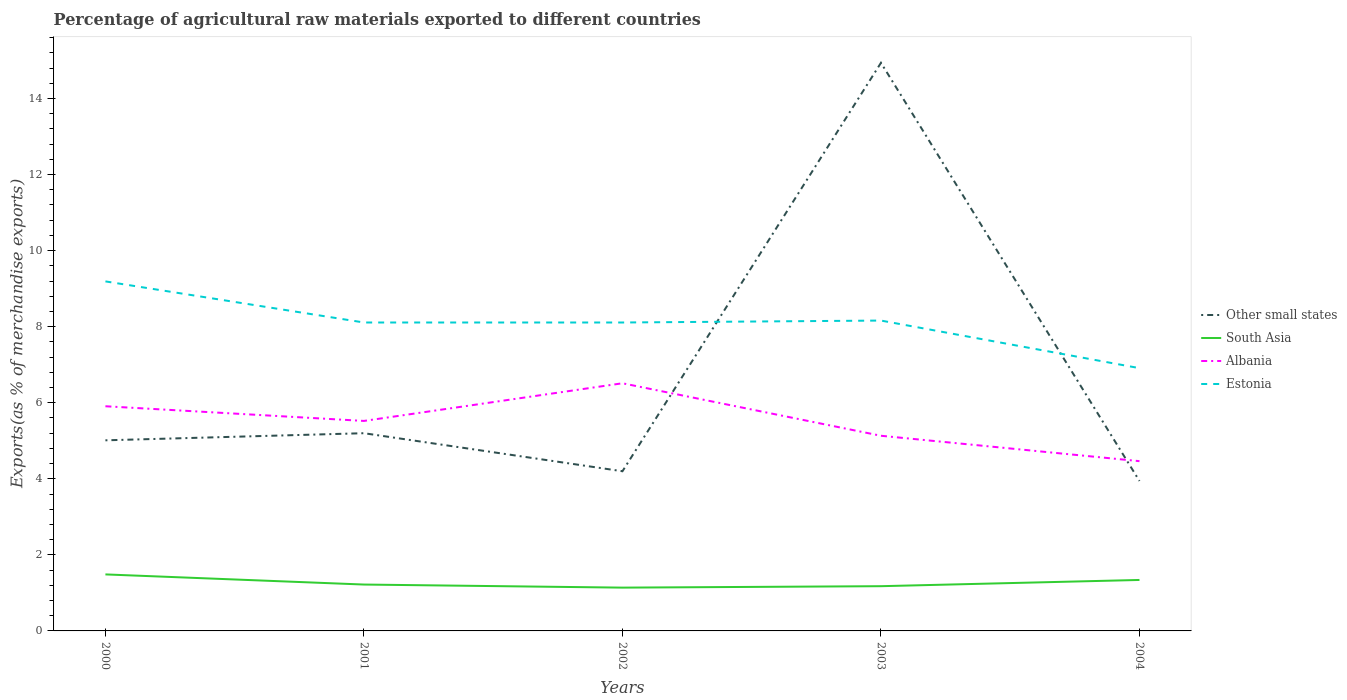Is the number of lines equal to the number of legend labels?
Make the answer very short. Yes. Across all years, what is the maximum percentage of exports to different countries in South Asia?
Provide a succinct answer. 1.14. In which year was the percentage of exports to different countries in Estonia maximum?
Offer a very short reply. 2004. What is the total percentage of exports to different countries in Albania in the graph?
Provide a succinct answer. -0.99. What is the difference between the highest and the second highest percentage of exports to different countries in Estonia?
Provide a short and direct response. 2.28. What is the difference between the highest and the lowest percentage of exports to different countries in Estonia?
Make the answer very short. 4. What is the difference between two consecutive major ticks on the Y-axis?
Your response must be concise. 2. Are the values on the major ticks of Y-axis written in scientific E-notation?
Provide a succinct answer. No. Does the graph contain any zero values?
Your response must be concise. No. Does the graph contain grids?
Keep it short and to the point. No. Where does the legend appear in the graph?
Give a very brief answer. Center right. How are the legend labels stacked?
Keep it short and to the point. Vertical. What is the title of the graph?
Give a very brief answer. Percentage of agricultural raw materials exported to different countries. What is the label or title of the Y-axis?
Your answer should be compact. Exports(as % of merchandise exports). What is the Exports(as % of merchandise exports) of Other small states in 2000?
Offer a very short reply. 5.01. What is the Exports(as % of merchandise exports) in South Asia in 2000?
Make the answer very short. 1.49. What is the Exports(as % of merchandise exports) in Albania in 2000?
Provide a short and direct response. 5.91. What is the Exports(as % of merchandise exports) of Estonia in 2000?
Offer a very short reply. 9.19. What is the Exports(as % of merchandise exports) of Other small states in 2001?
Your answer should be very brief. 5.2. What is the Exports(as % of merchandise exports) in South Asia in 2001?
Offer a very short reply. 1.22. What is the Exports(as % of merchandise exports) of Albania in 2001?
Ensure brevity in your answer.  5.52. What is the Exports(as % of merchandise exports) of Estonia in 2001?
Your response must be concise. 8.11. What is the Exports(as % of merchandise exports) of Other small states in 2002?
Your answer should be very brief. 4.2. What is the Exports(as % of merchandise exports) of South Asia in 2002?
Give a very brief answer. 1.14. What is the Exports(as % of merchandise exports) of Albania in 2002?
Provide a succinct answer. 6.51. What is the Exports(as % of merchandise exports) in Estonia in 2002?
Your answer should be compact. 8.11. What is the Exports(as % of merchandise exports) of Other small states in 2003?
Your response must be concise. 14.94. What is the Exports(as % of merchandise exports) in South Asia in 2003?
Ensure brevity in your answer.  1.18. What is the Exports(as % of merchandise exports) in Albania in 2003?
Your answer should be compact. 5.13. What is the Exports(as % of merchandise exports) of Estonia in 2003?
Your answer should be compact. 8.16. What is the Exports(as % of merchandise exports) in Other small states in 2004?
Make the answer very short. 3.94. What is the Exports(as % of merchandise exports) of South Asia in 2004?
Offer a terse response. 1.34. What is the Exports(as % of merchandise exports) of Albania in 2004?
Offer a very short reply. 4.46. What is the Exports(as % of merchandise exports) of Estonia in 2004?
Your answer should be very brief. 6.91. Across all years, what is the maximum Exports(as % of merchandise exports) in Other small states?
Your answer should be compact. 14.94. Across all years, what is the maximum Exports(as % of merchandise exports) of South Asia?
Your answer should be compact. 1.49. Across all years, what is the maximum Exports(as % of merchandise exports) of Albania?
Offer a very short reply. 6.51. Across all years, what is the maximum Exports(as % of merchandise exports) of Estonia?
Offer a very short reply. 9.19. Across all years, what is the minimum Exports(as % of merchandise exports) of Other small states?
Your answer should be very brief. 3.94. Across all years, what is the minimum Exports(as % of merchandise exports) of South Asia?
Your response must be concise. 1.14. Across all years, what is the minimum Exports(as % of merchandise exports) in Albania?
Offer a very short reply. 4.46. Across all years, what is the minimum Exports(as % of merchandise exports) in Estonia?
Provide a succinct answer. 6.91. What is the total Exports(as % of merchandise exports) in Other small states in the graph?
Make the answer very short. 33.29. What is the total Exports(as % of merchandise exports) in South Asia in the graph?
Your answer should be compact. 6.36. What is the total Exports(as % of merchandise exports) in Albania in the graph?
Offer a terse response. 27.54. What is the total Exports(as % of merchandise exports) of Estonia in the graph?
Give a very brief answer. 40.48. What is the difference between the Exports(as % of merchandise exports) in Other small states in 2000 and that in 2001?
Ensure brevity in your answer.  -0.19. What is the difference between the Exports(as % of merchandise exports) in South Asia in 2000 and that in 2001?
Offer a very short reply. 0.27. What is the difference between the Exports(as % of merchandise exports) in Albania in 2000 and that in 2001?
Make the answer very short. 0.39. What is the difference between the Exports(as % of merchandise exports) of Estonia in 2000 and that in 2001?
Your answer should be compact. 1.08. What is the difference between the Exports(as % of merchandise exports) of Other small states in 2000 and that in 2002?
Make the answer very short. 0.81. What is the difference between the Exports(as % of merchandise exports) of South Asia in 2000 and that in 2002?
Make the answer very short. 0.35. What is the difference between the Exports(as % of merchandise exports) in Albania in 2000 and that in 2002?
Make the answer very short. -0.6. What is the difference between the Exports(as % of merchandise exports) in Estonia in 2000 and that in 2002?
Ensure brevity in your answer.  1.08. What is the difference between the Exports(as % of merchandise exports) of Other small states in 2000 and that in 2003?
Give a very brief answer. -9.93. What is the difference between the Exports(as % of merchandise exports) of South Asia in 2000 and that in 2003?
Offer a terse response. 0.31. What is the difference between the Exports(as % of merchandise exports) in Albania in 2000 and that in 2003?
Keep it short and to the point. 0.78. What is the difference between the Exports(as % of merchandise exports) of Estonia in 2000 and that in 2003?
Your answer should be compact. 1.03. What is the difference between the Exports(as % of merchandise exports) of Other small states in 2000 and that in 2004?
Provide a short and direct response. 1.07. What is the difference between the Exports(as % of merchandise exports) of South Asia in 2000 and that in 2004?
Your answer should be compact. 0.15. What is the difference between the Exports(as % of merchandise exports) of Albania in 2000 and that in 2004?
Provide a short and direct response. 1.44. What is the difference between the Exports(as % of merchandise exports) in Estonia in 2000 and that in 2004?
Keep it short and to the point. 2.28. What is the difference between the Exports(as % of merchandise exports) of Other small states in 2001 and that in 2002?
Keep it short and to the point. 1. What is the difference between the Exports(as % of merchandise exports) of South Asia in 2001 and that in 2002?
Give a very brief answer. 0.08. What is the difference between the Exports(as % of merchandise exports) of Albania in 2001 and that in 2002?
Give a very brief answer. -0.99. What is the difference between the Exports(as % of merchandise exports) in Other small states in 2001 and that in 2003?
Give a very brief answer. -9.74. What is the difference between the Exports(as % of merchandise exports) in South Asia in 2001 and that in 2003?
Provide a succinct answer. 0.04. What is the difference between the Exports(as % of merchandise exports) of Albania in 2001 and that in 2003?
Give a very brief answer. 0.39. What is the difference between the Exports(as % of merchandise exports) of Estonia in 2001 and that in 2003?
Your response must be concise. -0.05. What is the difference between the Exports(as % of merchandise exports) in Other small states in 2001 and that in 2004?
Offer a very short reply. 1.26. What is the difference between the Exports(as % of merchandise exports) in South Asia in 2001 and that in 2004?
Make the answer very short. -0.12. What is the difference between the Exports(as % of merchandise exports) of Albania in 2001 and that in 2004?
Your response must be concise. 1.06. What is the difference between the Exports(as % of merchandise exports) of Estonia in 2001 and that in 2004?
Offer a terse response. 1.2. What is the difference between the Exports(as % of merchandise exports) of Other small states in 2002 and that in 2003?
Provide a short and direct response. -10.74. What is the difference between the Exports(as % of merchandise exports) in South Asia in 2002 and that in 2003?
Offer a very short reply. -0.04. What is the difference between the Exports(as % of merchandise exports) of Albania in 2002 and that in 2003?
Your answer should be compact. 1.38. What is the difference between the Exports(as % of merchandise exports) in Estonia in 2002 and that in 2003?
Make the answer very short. -0.05. What is the difference between the Exports(as % of merchandise exports) in Other small states in 2002 and that in 2004?
Provide a succinct answer. 0.26. What is the difference between the Exports(as % of merchandise exports) in South Asia in 2002 and that in 2004?
Ensure brevity in your answer.  -0.2. What is the difference between the Exports(as % of merchandise exports) in Albania in 2002 and that in 2004?
Your answer should be compact. 2.05. What is the difference between the Exports(as % of merchandise exports) of Estonia in 2002 and that in 2004?
Ensure brevity in your answer.  1.2. What is the difference between the Exports(as % of merchandise exports) in Other small states in 2003 and that in 2004?
Provide a short and direct response. 11. What is the difference between the Exports(as % of merchandise exports) of South Asia in 2003 and that in 2004?
Your answer should be compact. -0.16. What is the difference between the Exports(as % of merchandise exports) in Albania in 2003 and that in 2004?
Make the answer very short. 0.67. What is the difference between the Exports(as % of merchandise exports) of Estonia in 2003 and that in 2004?
Your answer should be compact. 1.25. What is the difference between the Exports(as % of merchandise exports) of Other small states in 2000 and the Exports(as % of merchandise exports) of South Asia in 2001?
Provide a short and direct response. 3.79. What is the difference between the Exports(as % of merchandise exports) in Other small states in 2000 and the Exports(as % of merchandise exports) in Albania in 2001?
Provide a succinct answer. -0.51. What is the difference between the Exports(as % of merchandise exports) of Other small states in 2000 and the Exports(as % of merchandise exports) of Estonia in 2001?
Your response must be concise. -3.1. What is the difference between the Exports(as % of merchandise exports) in South Asia in 2000 and the Exports(as % of merchandise exports) in Albania in 2001?
Provide a short and direct response. -4.04. What is the difference between the Exports(as % of merchandise exports) of South Asia in 2000 and the Exports(as % of merchandise exports) of Estonia in 2001?
Your response must be concise. -6.62. What is the difference between the Exports(as % of merchandise exports) in Albania in 2000 and the Exports(as % of merchandise exports) in Estonia in 2001?
Offer a very short reply. -2.2. What is the difference between the Exports(as % of merchandise exports) of Other small states in 2000 and the Exports(as % of merchandise exports) of South Asia in 2002?
Offer a very short reply. 3.87. What is the difference between the Exports(as % of merchandise exports) of Other small states in 2000 and the Exports(as % of merchandise exports) of Albania in 2002?
Ensure brevity in your answer.  -1.5. What is the difference between the Exports(as % of merchandise exports) of Other small states in 2000 and the Exports(as % of merchandise exports) of Estonia in 2002?
Provide a short and direct response. -3.1. What is the difference between the Exports(as % of merchandise exports) of South Asia in 2000 and the Exports(as % of merchandise exports) of Albania in 2002?
Offer a very short reply. -5.03. What is the difference between the Exports(as % of merchandise exports) in South Asia in 2000 and the Exports(as % of merchandise exports) in Estonia in 2002?
Provide a short and direct response. -6.62. What is the difference between the Exports(as % of merchandise exports) of Albania in 2000 and the Exports(as % of merchandise exports) of Estonia in 2002?
Offer a very short reply. -2.2. What is the difference between the Exports(as % of merchandise exports) in Other small states in 2000 and the Exports(as % of merchandise exports) in South Asia in 2003?
Ensure brevity in your answer.  3.84. What is the difference between the Exports(as % of merchandise exports) in Other small states in 2000 and the Exports(as % of merchandise exports) in Albania in 2003?
Offer a very short reply. -0.12. What is the difference between the Exports(as % of merchandise exports) in Other small states in 2000 and the Exports(as % of merchandise exports) in Estonia in 2003?
Make the answer very short. -3.15. What is the difference between the Exports(as % of merchandise exports) of South Asia in 2000 and the Exports(as % of merchandise exports) of Albania in 2003?
Give a very brief answer. -3.65. What is the difference between the Exports(as % of merchandise exports) of South Asia in 2000 and the Exports(as % of merchandise exports) of Estonia in 2003?
Give a very brief answer. -6.67. What is the difference between the Exports(as % of merchandise exports) in Albania in 2000 and the Exports(as % of merchandise exports) in Estonia in 2003?
Provide a succinct answer. -2.25. What is the difference between the Exports(as % of merchandise exports) in Other small states in 2000 and the Exports(as % of merchandise exports) in South Asia in 2004?
Give a very brief answer. 3.67. What is the difference between the Exports(as % of merchandise exports) in Other small states in 2000 and the Exports(as % of merchandise exports) in Albania in 2004?
Offer a terse response. 0.55. What is the difference between the Exports(as % of merchandise exports) of Other small states in 2000 and the Exports(as % of merchandise exports) of Estonia in 2004?
Ensure brevity in your answer.  -1.9. What is the difference between the Exports(as % of merchandise exports) of South Asia in 2000 and the Exports(as % of merchandise exports) of Albania in 2004?
Give a very brief answer. -2.98. What is the difference between the Exports(as % of merchandise exports) of South Asia in 2000 and the Exports(as % of merchandise exports) of Estonia in 2004?
Offer a very short reply. -5.42. What is the difference between the Exports(as % of merchandise exports) of Albania in 2000 and the Exports(as % of merchandise exports) of Estonia in 2004?
Keep it short and to the point. -1. What is the difference between the Exports(as % of merchandise exports) of Other small states in 2001 and the Exports(as % of merchandise exports) of South Asia in 2002?
Offer a very short reply. 4.06. What is the difference between the Exports(as % of merchandise exports) of Other small states in 2001 and the Exports(as % of merchandise exports) of Albania in 2002?
Keep it short and to the point. -1.31. What is the difference between the Exports(as % of merchandise exports) in Other small states in 2001 and the Exports(as % of merchandise exports) in Estonia in 2002?
Offer a very short reply. -2.91. What is the difference between the Exports(as % of merchandise exports) of South Asia in 2001 and the Exports(as % of merchandise exports) of Albania in 2002?
Offer a very short reply. -5.29. What is the difference between the Exports(as % of merchandise exports) in South Asia in 2001 and the Exports(as % of merchandise exports) in Estonia in 2002?
Your answer should be compact. -6.89. What is the difference between the Exports(as % of merchandise exports) in Albania in 2001 and the Exports(as % of merchandise exports) in Estonia in 2002?
Provide a succinct answer. -2.59. What is the difference between the Exports(as % of merchandise exports) of Other small states in 2001 and the Exports(as % of merchandise exports) of South Asia in 2003?
Provide a short and direct response. 4.02. What is the difference between the Exports(as % of merchandise exports) of Other small states in 2001 and the Exports(as % of merchandise exports) of Albania in 2003?
Offer a very short reply. 0.07. What is the difference between the Exports(as % of merchandise exports) of Other small states in 2001 and the Exports(as % of merchandise exports) of Estonia in 2003?
Offer a very short reply. -2.96. What is the difference between the Exports(as % of merchandise exports) in South Asia in 2001 and the Exports(as % of merchandise exports) in Albania in 2003?
Your response must be concise. -3.91. What is the difference between the Exports(as % of merchandise exports) of South Asia in 2001 and the Exports(as % of merchandise exports) of Estonia in 2003?
Make the answer very short. -6.94. What is the difference between the Exports(as % of merchandise exports) in Albania in 2001 and the Exports(as % of merchandise exports) in Estonia in 2003?
Ensure brevity in your answer.  -2.64. What is the difference between the Exports(as % of merchandise exports) of Other small states in 2001 and the Exports(as % of merchandise exports) of South Asia in 2004?
Give a very brief answer. 3.86. What is the difference between the Exports(as % of merchandise exports) in Other small states in 2001 and the Exports(as % of merchandise exports) in Albania in 2004?
Offer a very short reply. 0.74. What is the difference between the Exports(as % of merchandise exports) in Other small states in 2001 and the Exports(as % of merchandise exports) in Estonia in 2004?
Give a very brief answer. -1.71. What is the difference between the Exports(as % of merchandise exports) in South Asia in 2001 and the Exports(as % of merchandise exports) in Albania in 2004?
Ensure brevity in your answer.  -3.24. What is the difference between the Exports(as % of merchandise exports) of South Asia in 2001 and the Exports(as % of merchandise exports) of Estonia in 2004?
Your answer should be very brief. -5.69. What is the difference between the Exports(as % of merchandise exports) of Albania in 2001 and the Exports(as % of merchandise exports) of Estonia in 2004?
Make the answer very short. -1.39. What is the difference between the Exports(as % of merchandise exports) in Other small states in 2002 and the Exports(as % of merchandise exports) in South Asia in 2003?
Ensure brevity in your answer.  3.02. What is the difference between the Exports(as % of merchandise exports) in Other small states in 2002 and the Exports(as % of merchandise exports) in Albania in 2003?
Your answer should be compact. -0.93. What is the difference between the Exports(as % of merchandise exports) in Other small states in 2002 and the Exports(as % of merchandise exports) in Estonia in 2003?
Give a very brief answer. -3.96. What is the difference between the Exports(as % of merchandise exports) in South Asia in 2002 and the Exports(as % of merchandise exports) in Albania in 2003?
Offer a very short reply. -3.99. What is the difference between the Exports(as % of merchandise exports) of South Asia in 2002 and the Exports(as % of merchandise exports) of Estonia in 2003?
Give a very brief answer. -7.02. What is the difference between the Exports(as % of merchandise exports) of Albania in 2002 and the Exports(as % of merchandise exports) of Estonia in 2003?
Ensure brevity in your answer.  -1.65. What is the difference between the Exports(as % of merchandise exports) of Other small states in 2002 and the Exports(as % of merchandise exports) of South Asia in 2004?
Give a very brief answer. 2.86. What is the difference between the Exports(as % of merchandise exports) in Other small states in 2002 and the Exports(as % of merchandise exports) in Albania in 2004?
Give a very brief answer. -0.27. What is the difference between the Exports(as % of merchandise exports) in Other small states in 2002 and the Exports(as % of merchandise exports) in Estonia in 2004?
Provide a short and direct response. -2.71. What is the difference between the Exports(as % of merchandise exports) in South Asia in 2002 and the Exports(as % of merchandise exports) in Albania in 2004?
Offer a very short reply. -3.33. What is the difference between the Exports(as % of merchandise exports) in South Asia in 2002 and the Exports(as % of merchandise exports) in Estonia in 2004?
Keep it short and to the point. -5.77. What is the difference between the Exports(as % of merchandise exports) of Albania in 2002 and the Exports(as % of merchandise exports) of Estonia in 2004?
Your answer should be very brief. -0.4. What is the difference between the Exports(as % of merchandise exports) of Other small states in 2003 and the Exports(as % of merchandise exports) of South Asia in 2004?
Keep it short and to the point. 13.6. What is the difference between the Exports(as % of merchandise exports) of Other small states in 2003 and the Exports(as % of merchandise exports) of Albania in 2004?
Keep it short and to the point. 10.47. What is the difference between the Exports(as % of merchandise exports) of Other small states in 2003 and the Exports(as % of merchandise exports) of Estonia in 2004?
Your response must be concise. 8.03. What is the difference between the Exports(as % of merchandise exports) of South Asia in 2003 and the Exports(as % of merchandise exports) of Albania in 2004?
Your answer should be very brief. -3.29. What is the difference between the Exports(as % of merchandise exports) of South Asia in 2003 and the Exports(as % of merchandise exports) of Estonia in 2004?
Make the answer very short. -5.73. What is the difference between the Exports(as % of merchandise exports) of Albania in 2003 and the Exports(as % of merchandise exports) of Estonia in 2004?
Offer a terse response. -1.78. What is the average Exports(as % of merchandise exports) of Other small states per year?
Make the answer very short. 6.66. What is the average Exports(as % of merchandise exports) of South Asia per year?
Your response must be concise. 1.27. What is the average Exports(as % of merchandise exports) in Albania per year?
Make the answer very short. 5.51. What is the average Exports(as % of merchandise exports) of Estonia per year?
Your response must be concise. 8.1. In the year 2000, what is the difference between the Exports(as % of merchandise exports) in Other small states and Exports(as % of merchandise exports) in South Asia?
Offer a very short reply. 3.53. In the year 2000, what is the difference between the Exports(as % of merchandise exports) in Other small states and Exports(as % of merchandise exports) in Albania?
Ensure brevity in your answer.  -0.9. In the year 2000, what is the difference between the Exports(as % of merchandise exports) of Other small states and Exports(as % of merchandise exports) of Estonia?
Your answer should be compact. -4.18. In the year 2000, what is the difference between the Exports(as % of merchandise exports) in South Asia and Exports(as % of merchandise exports) in Albania?
Offer a terse response. -4.42. In the year 2000, what is the difference between the Exports(as % of merchandise exports) in South Asia and Exports(as % of merchandise exports) in Estonia?
Your answer should be very brief. -7.7. In the year 2000, what is the difference between the Exports(as % of merchandise exports) of Albania and Exports(as % of merchandise exports) of Estonia?
Keep it short and to the point. -3.28. In the year 2001, what is the difference between the Exports(as % of merchandise exports) in Other small states and Exports(as % of merchandise exports) in South Asia?
Your response must be concise. 3.98. In the year 2001, what is the difference between the Exports(as % of merchandise exports) in Other small states and Exports(as % of merchandise exports) in Albania?
Provide a short and direct response. -0.32. In the year 2001, what is the difference between the Exports(as % of merchandise exports) in Other small states and Exports(as % of merchandise exports) in Estonia?
Offer a very short reply. -2.91. In the year 2001, what is the difference between the Exports(as % of merchandise exports) of South Asia and Exports(as % of merchandise exports) of Albania?
Ensure brevity in your answer.  -4.3. In the year 2001, what is the difference between the Exports(as % of merchandise exports) of South Asia and Exports(as % of merchandise exports) of Estonia?
Make the answer very short. -6.89. In the year 2001, what is the difference between the Exports(as % of merchandise exports) in Albania and Exports(as % of merchandise exports) in Estonia?
Provide a short and direct response. -2.59. In the year 2002, what is the difference between the Exports(as % of merchandise exports) of Other small states and Exports(as % of merchandise exports) of South Asia?
Provide a short and direct response. 3.06. In the year 2002, what is the difference between the Exports(as % of merchandise exports) in Other small states and Exports(as % of merchandise exports) in Albania?
Provide a short and direct response. -2.31. In the year 2002, what is the difference between the Exports(as % of merchandise exports) of Other small states and Exports(as % of merchandise exports) of Estonia?
Make the answer very short. -3.91. In the year 2002, what is the difference between the Exports(as % of merchandise exports) of South Asia and Exports(as % of merchandise exports) of Albania?
Offer a terse response. -5.37. In the year 2002, what is the difference between the Exports(as % of merchandise exports) in South Asia and Exports(as % of merchandise exports) in Estonia?
Your answer should be compact. -6.97. In the year 2002, what is the difference between the Exports(as % of merchandise exports) in Albania and Exports(as % of merchandise exports) in Estonia?
Ensure brevity in your answer.  -1.6. In the year 2003, what is the difference between the Exports(as % of merchandise exports) of Other small states and Exports(as % of merchandise exports) of South Asia?
Offer a terse response. 13.76. In the year 2003, what is the difference between the Exports(as % of merchandise exports) of Other small states and Exports(as % of merchandise exports) of Albania?
Ensure brevity in your answer.  9.81. In the year 2003, what is the difference between the Exports(as % of merchandise exports) in Other small states and Exports(as % of merchandise exports) in Estonia?
Make the answer very short. 6.78. In the year 2003, what is the difference between the Exports(as % of merchandise exports) in South Asia and Exports(as % of merchandise exports) in Albania?
Ensure brevity in your answer.  -3.96. In the year 2003, what is the difference between the Exports(as % of merchandise exports) in South Asia and Exports(as % of merchandise exports) in Estonia?
Offer a very short reply. -6.98. In the year 2003, what is the difference between the Exports(as % of merchandise exports) of Albania and Exports(as % of merchandise exports) of Estonia?
Give a very brief answer. -3.03. In the year 2004, what is the difference between the Exports(as % of merchandise exports) in Other small states and Exports(as % of merchandise exports) in South Asia?
Offer a terse response. 2.6. In the year 2004, what is the difference between the Exports(as % of merchandise exports) in Other small states and Exports(as % of merchandise exports) in Albania?
Provide a succinct answer. -0.52. In the year 2004, what is the difference between the Exports(as % of merchandise exports) of Other small states and Exports(as % of merchandise exports) of Estonia?
Make the answer very short. -2.97. In the year 2004, what is the difference between the Exports(as % of merchandise exports) of South Asia and Exports(as % of merchandise exports) of Albania?
Provide a succinct answer. -3.12. In the year 2004, what is the difference between the Exports(as % of merchandise exports) of South Asia and Exports(as % of merchandise exports) of Estonia?
Keep it short and to the point. -5.57. In the year 2004, what is the difference between the Exports(as % of merchandise exports) of Albania and Exports(as % of merchandise exports) of Estonia?
Your answer should be very brief. -2.45. What is the ratio of the Exports(as % of merchandise exports) in South Asia in 2000 to that in 2001?
Keep it short and to the point. 1.22. What is the ratio of the Exports(as % of merchandise exports) in Albania in 2000 to that in 2001?
Make the answer very short. 1.07. What is the ratio of the Exports(as % of merchandise exports) of Estonia in 2000 to that in 2001?
Offer a very short reply. 1.13. What is the ratio of the Exports(as % of merchandise exports) in Other small states in 2000 to that in 2002?
Ensure brevity in your answer.  1.19. What is the ratio of the Exports(as % of merchandise exports) of South Asia in 2000 to that in 2002?
Make the answer very short. 1.31. What is the ratio of the Exports(as % of merchandise exports) of Albania in 2000 to that in 2002?
Keep it short and to the point. 0.91. What is the ratio of the Exports(as % of merchandise exports) in Estonia in 2000 to that in 2002?
Give a very brief answer. 1.13. What is the ratio of the Exports(as % of merchandise exports) of Other small states in 2000 to that in 2003?
Provide a short and direct response. 0.34. What is the ratio of the Exports(as % of merchandise exports) in South Asia in 2000 to that in 2003?
Offer a terse response. 1.26. What is the ratio of the Exports(as % of merchandise exports) of Albania in 2000 to that in 2003?
Offer a terse response. 1.15. What is the ratio of the Exports(as % of merchandise exports) of Estonia in 2000 to that in 2003?
Make the answer very short. 1.13. What is the ratio of the Exports(as % of merchandise exports) in Other small states in 2000 to that in 2004?
Give a very brief answer. 1.27. What is the ratio of the Exports(as % of merchandise exports) of South Asia in 2000 to that in 2004?
Keep it short and to the point. 1.11. What is the ratio of the Exports(as % of merchandise exports) in Albania in 2000 to that in 2004?
Provide a short and direct response. 1.32. What is the ratio of the Exports(as % of merchandise exports) in Estonia in 2000 to that in 2004?
Offer a terse response. 1.33. What is the ratio of the Exports(as % of merchandise exports) of Other small states in 2001 to that in 2002?
Offer a terse response. 1.24. What is the ratio of the Exports(as % of merchandise exports) in South Asia in 2001 to that in 2002?
Offer a very short reply. 1.07. What is the ratio of the Exports(as % of merchandise exports) of Albania in 2001 to that in 2002?
Your response must be concise. 0.85. What is the ratio of the Exports(as % of merchandise exports) in Estonia in 2001 to that in 2002?
Your response must be concise. 1. What is the ratio of the Exports(as % of merchandise exports) in Other small states in 2001 to that in 2003?
Offer a very short reply. 0.35. What is the ratio of the Exports(as % of merchandise exports) of South Asia in 2001 to that in 2003?
Your response must be concise. 1.04. What is the ratio of the Exports(as % of merchandise exports) in Albania in 2001 to that in 2003?
Your answer should be very brief. 1.08. What is the ratio of the Exports(as % of merchandise exports) of Estonia in 2001 to that in 2003?
Your answer should be very brief. 0.99. What is the ratio of the Exports(as % of merchandise exports) of Other small states in 2001 to that in 2004?
Your answer should be very brief. 1.32. What is the ratio of the Exports(as % of merchandise exports) in South Asia in 2001 to that in 2004?
Provide a succinct answer. 0.91. What is the ratio of the Exports(as % of merchandise exports) of Albania in 2001 to that in 2004?
Ensure brevity in your answer.  1.24. What is the ratio of the Exports(as % of merchandise exports) of Estonia in 2001 to that in 2004?
Offer a very short reply. 1.17. What is the ratio of the Exports(as % of merchandise exports) of Other small states in 2002 to that in 2003?
Ensure brevity in your answer.  0.28. What is the ratio of the Exports(as % of merchandise exports) in Albania in 2002 to that in 2003?
Make the answer very short. 1.27. What is the ratio of the Exports(as % of merchandise exports) of Estonia in 2002 to that in 2003?
Make the answer very short. 0.99. What is the ratio of the Exports(as % of merchandise exports) in Other small states in 2002 to that in 2004?
Your answer should be very brief. 1.06. What is the ratio of the Exports(as % of merchandise exports) in South Asia in 2002 to that in 2004?
Your answer should be very brief. 0.85. What is the ratio of the Exports(as % of merchandise exports) of Albania in 2002 to that in 2004?
Keep it short and to the point. 1.46. What is the ratio of the Exports(as % of merchandise exports) in Estonia in 2002 to that in 2004?
Offer a terse response. 1.17. What is the ratio of the Exports(as % of merchandise exports) of Other small states in 2003 to that in 2004?
Offer a very short reply. 3.79. What is the ratio of the Exports(as % of merchandise exports) in South Asia in 2003 to that in 2004?
Your answer should be compact. 0.88. What is the ratio of the Exports(as % of merchandise exports) in Albania in 2003 to that in 2004?
Make the answer very short. 1.15. What is the ratio of the Exports(as % of merchandise exports) in Estonia in 2003 to that in 2004?
Your answer should be compact. 1.18. What is the difference between the highest and the second highest Exports(as % of merchandise exports) in Other small states?
Make the answer very short. 9.74. What is the difference between the highest and the second highest Exports(as % of merchandise exports) in South Asia?
Offer a terse response. 0.15. What is the difference between the highest and the second highest Exports(as % of merchandise exports) of Albania?
Keep it short and to the point. 0.6. What is the difference between the highest and the second highest Exports(as % of merchandise exports) in Estonia?
Offer a very short reply. 1.03. What is the difference between the highest and the lowest Exports(as % of merchandise exports) of Other small states?
Keep it short and to the point. 11. What is the difference between the highest and the lowest Exports(as % of merchandise exports) of South Asia?
Ensure brevity in your answer.  0.35. What is the difference between the highest and the lowest Exports(as % of merchandise exports) of Albania?
Your response must be concise. 2.05. What is the difference between the highest and the lowest Exports(as % of merchandise exports) of Estonia?
Offer a very short reply. 2.28. 